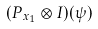<formula> <loc_0><loc_0><loc_500><loc_500>( P _ { x _ { 1 } } \otimes I ) ( \psi )</formula> 